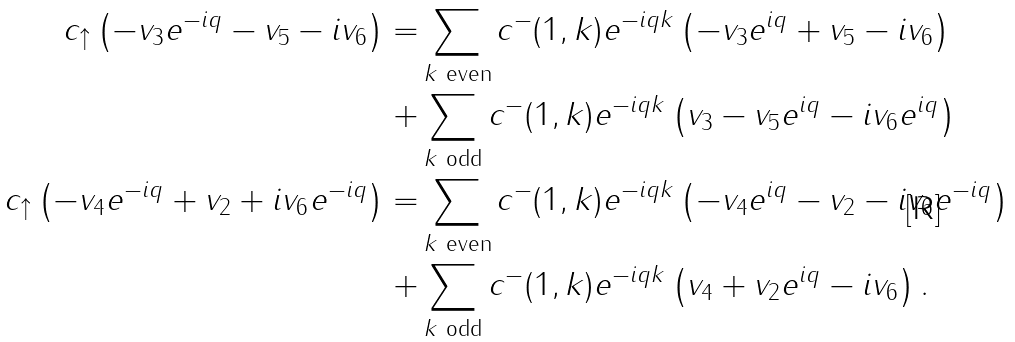Convert formula to latex. <formula><loc_0><loc_0><loc_500><loc_500>c _ { \uparrow } \left ( - v _ { 3 } e ^ { - i q } - v _ { 5 } - i v _ { 6 } \right ) = & \sum _ { k \text { even} } c ^ { - } ( 1 , k ) e ^ { - i q k } \left ( - v _ { 3 } e ^ { i q } + v _ { 5 } - i v _ { 6 } \right ) \\ + & \sum _ { k \text { odd} } c ^ { - } ( 1 , k ) e ^ { - i q k } \left ( v _ { 3 } - v _ { 5 } e ^ { i q } - i v _ { 6 } e ^ { i q } \right ) \\ c _ { \uparrow } \left ( - v _ { 4 } e ^ { - i q } + v _ { 2 } + i v _ { 6 } e ^ { - i q } \right ) = & \sum _ { k \text { even} } c ^ { - } ( 1 , k ) e ^ { - i q k } \left ( - v _ { 4 } e ^ { i q } - v _ { 2 } - i v _ { 6 } e ^ { - i q } \right ) \\ + & \sum _ { k \text { odd} } c ^ { - } ( 1 , k ) e ^ { - i q k } \left ( v _ { 4 } + v _ { 2 } e ^ { i q } - i v _ { 6 } \right ) .</formula> 